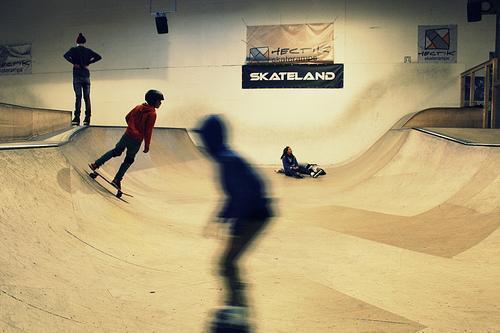How many people have on red?
Give a very brief answer. 1. How many people are standing on skateboards?
Give a very brief answer. 2. 